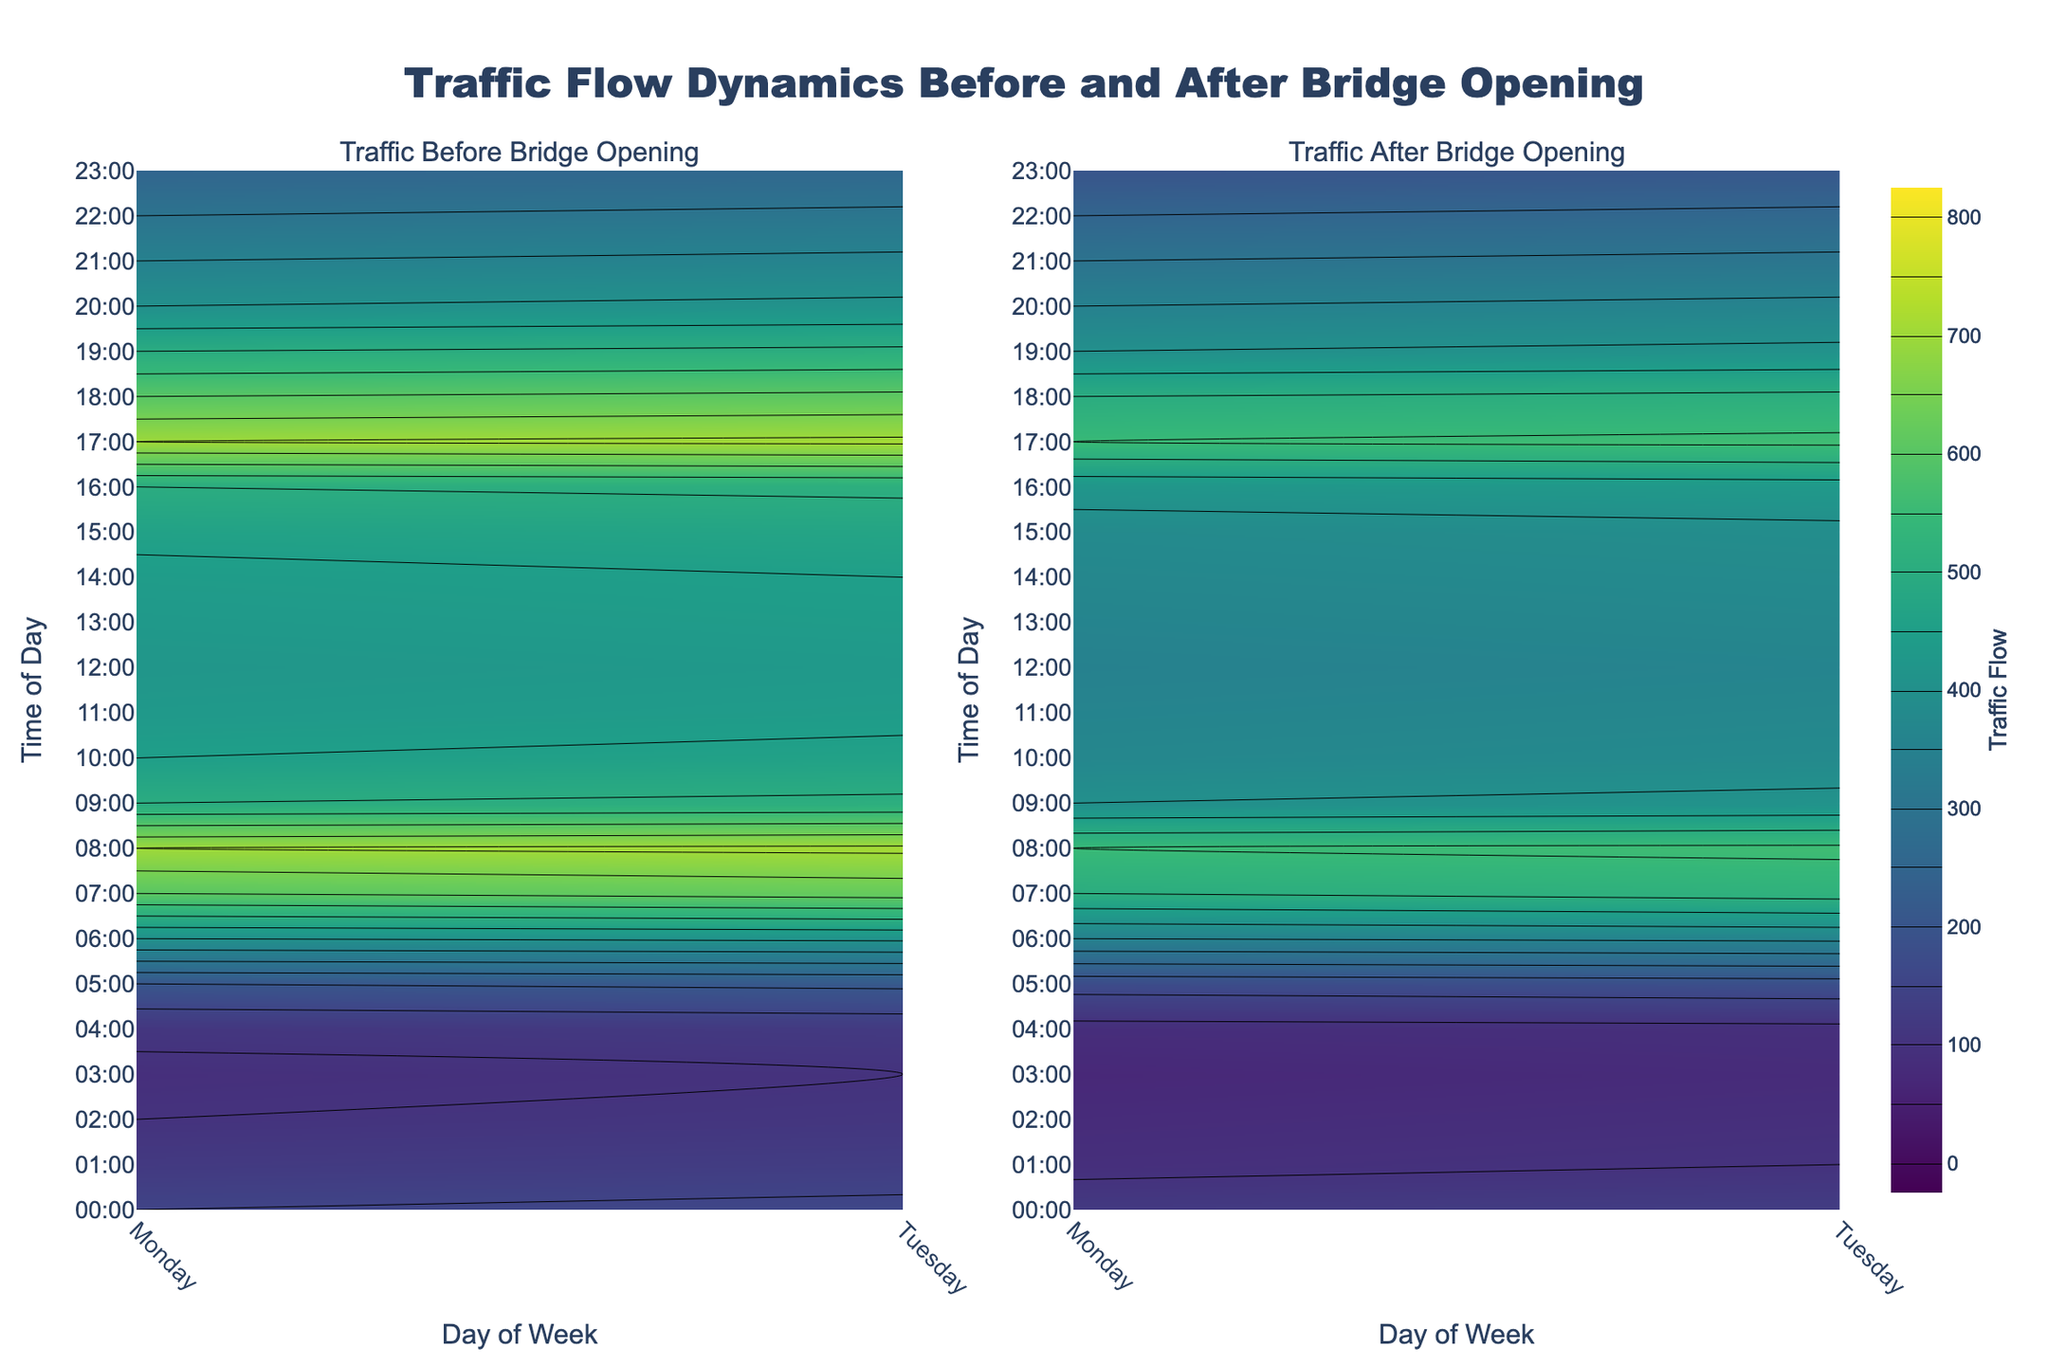What's the title of the figure? The title is usually displayed at the top of the figure. Based on the provided code, the title should be "Traffic Flow Dynamics Before and After Bridge Opening."
Answer: Traffic Flow Dynamics Before and After Bridge Opening What are the two subplots showing? The subplot titles are indicated in the provided code. They are "Traffic Before Bridge Opening" and "Traffic After Bridge Opening."
Answer: Traffic Before Bridge Opening and Traffic After Bridge Opening Which day of the week appears to have the highest traffic flow before the bridge opened? By observing the figure and comparing the contours, one can see that Tuesday and Monday exhibit the highest traffic flows, particularly around 7-8 AM and 5-6 PM. The highest peak is evident on Tuesday during these hours.
Answer: Tuesday How does the traffic flow at 6 AM compare before and after the bridge opening on Monday? Check the 6 AM row for Monday in both subplots. The plot should indicate that the traffic flow reduced from 400 to 350 after the bridge opened.
Answer: 400 vs 350 What time of day has the lowest traffic flow on Tuesday after the bridge opened? Look for the lowest value in the "Traffic After Bridge Opening" subplot for Tuesday. The figure shows that the lowest traffic occurs around 3-4 AM.
Answer: 3-4 AM Describe the overall trend in traffic flow throughout the day before the bridge opened. Observing the contour plot for the "Traffic Before Bridge Opening" subplot, there is a noticeable peak during morning hours (7-8 AM) and another in the evening (5-6 PM). The traffic flow gradually declines after evening peak hours.
Answer: Peaks during 7-8 AM and 5-6 PM, then declines Which time and day combination shows the maximum reduction in traffic flow? By comparing the contours in both subplots, the largest reduction is visible on Tuesday at 8 AM, where the traffic flow reduced from 710 to 560.
Answer: Tuesday at 8 AM How does evening traffic at 5 PM on Tuesday before and after the bridge opening compare? By comparing the 5 PM row of Tuesday in both subplots, the traffic flow decreased from 710 to 560 after the bridge opened.
Answer: 710 vs 560 